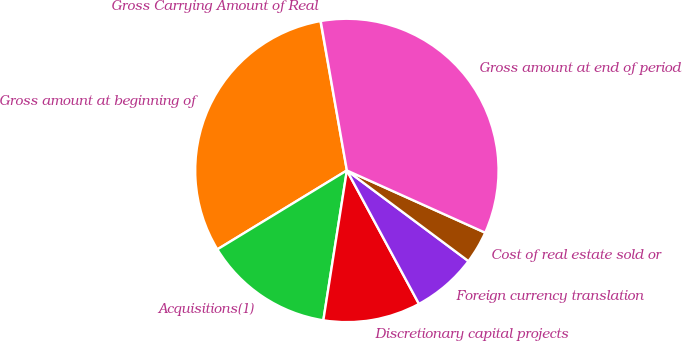Convert chart to OTSL. <chart><loc_0><loc_0><loc_500><loc_500><pie_chart><fcel>Gross Carrying Amount of Real<fcel>Gross amount at beginning of<fcel>Acquisitions(1)<fcel>Discretionary capital projects<fcel>Foreign currency translation<fcel>Cost of real estate sold or<fcel>Gross amount at end of period<nl><fcel>0.03%<fcel>30.92%<fcel>13.81%<fcel>10.36%<fcel>6.92%<fcel>3.47%<fcel>34.49%<nl></chart> 